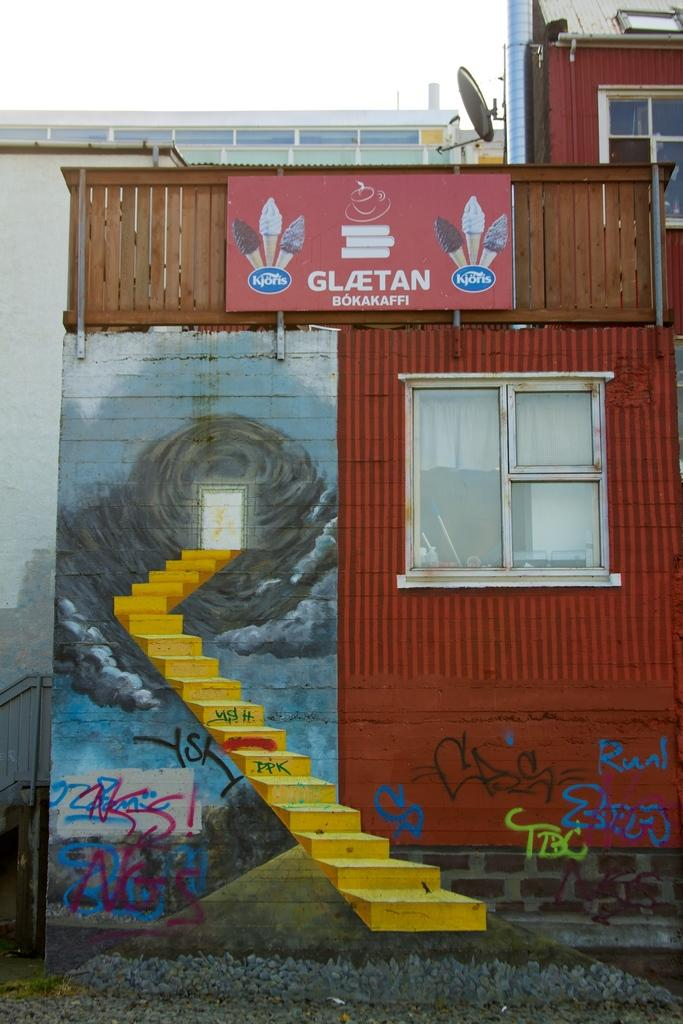What type of structure is visible in the picture? There is a building in the picture. What is depicted in the painting within the picture? The painting in the picture shows stairs. How would you describe the weather based on the sky in the picture? The sky is clear in the picture, suggesting good weather. Can you tell me how many times the wheel has been repaired in the picture? There is no wheel present in the picture, so it is not possible to determine how many times it has been repaired. 